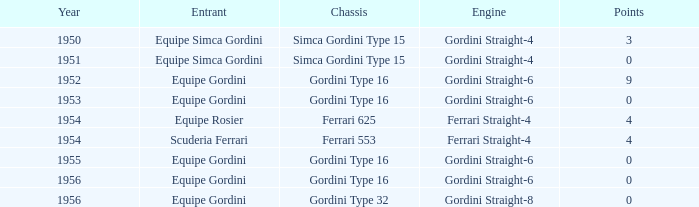What chassis has smaller than 9 points by Equipe Rosier? Ferrari 625. 